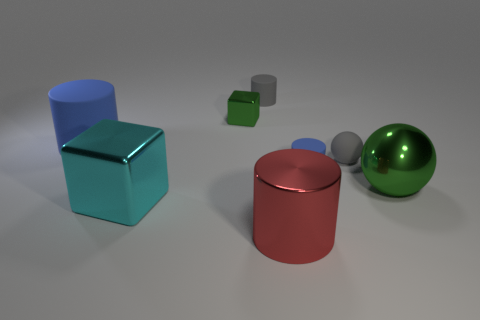Add 1 red metallic spheres. How many objects exist? 9 Subtract all cubes. How many objects are left? 6 Add 3 gray balls. How many gray balls are left? 4 Add 6 cyan metal objects. How many cyan metal objects exist? 7 Subtract 0 brown balls. How many objects are left? 8 Subtract all large red cylinders. Subtract all gray cylinders. How many objects are left? 6 